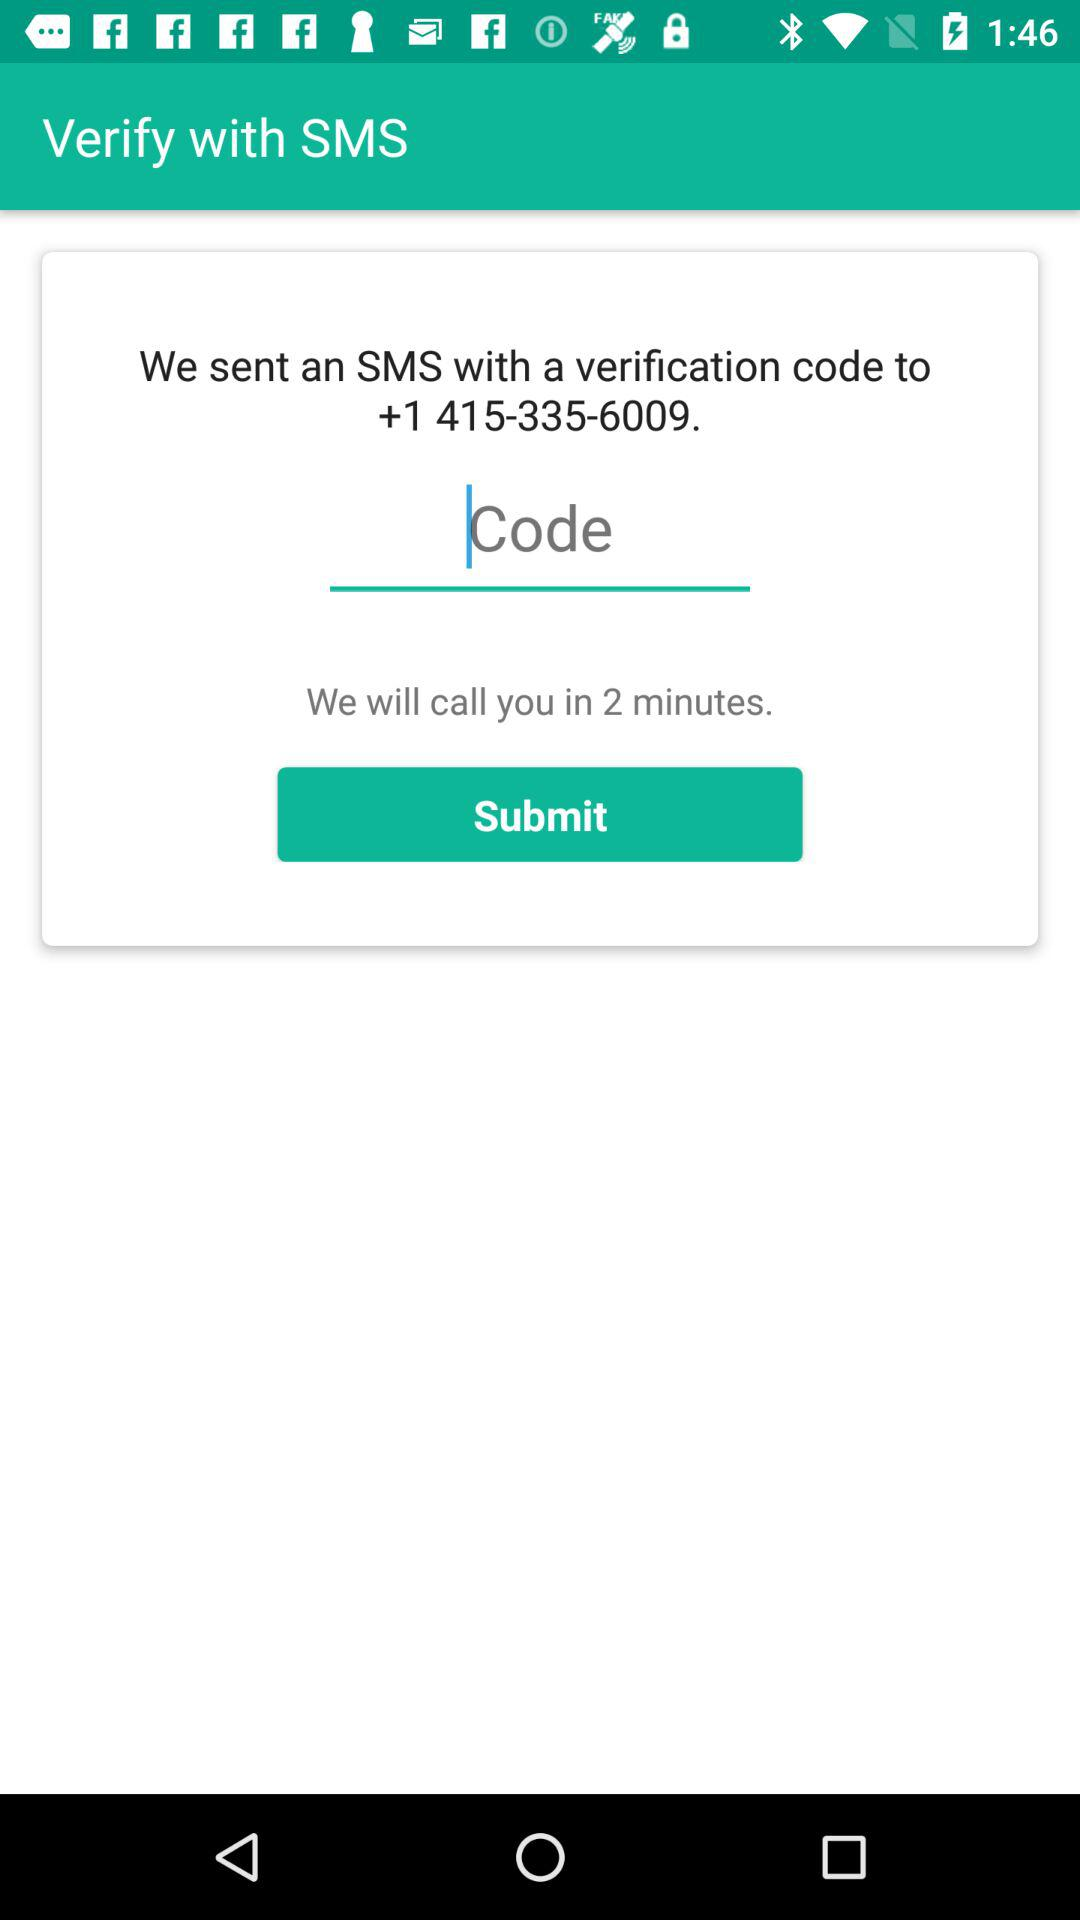In how many minutes will I receive a call? You will receive a call in 2 minutes. 